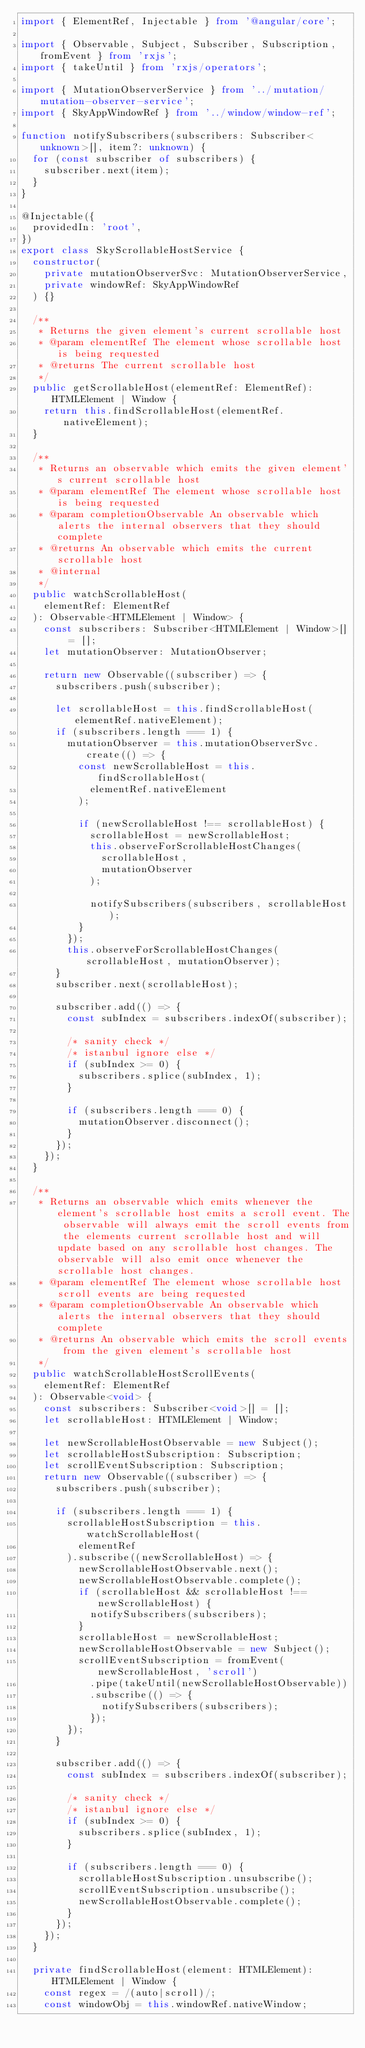Convert code to text. <code><loc_0><loc_0><loc_500><loc_500><_TypeScript_>import { ElementRef, Injectable } from '@angular/core';

import { Observable, Subject, Subscriber, Subscription, fromEvent } from 'rxjs';
import { takeUntil } from 'rxjs/operators';

import { MutationObserverService } from '../mutation/mutation-observer-service';
import { SkyAppWindowRef } from '../window/window-ref';

function notifySubscribers(subscribers: Subscriber<unknown>[], item?: unknown) {
  for (const subscriber of subscribers) {
    subscriber.next(item);
  }
}

@Injectable({
  providedIn: 'root',
})
export class SkyScrollableHostService {
  constructor(
    private mutationObserverSvc: MutationObserverService,
    private windowRef: SkyAppWindowRef
  ) {}

  /**
   * Returns the given element's current scrollable host
   * @param elementRef The element whose scrollable host is being requested
   * @returns The current scrollable host
   */
  public getScrollableHost(elementRef: ElementRef): HTMLElement | Window {
    return this.findScrollableHost(elementRef.nativeElement);
  }

  /**
   * Returns an observable which emits the given element's current scrollable host
   * @param elementRef The element whose scrollable host is being requested
   * @param completionObservable An observable which alerts the internal observers that they should complete
   * @returns An observable which emits the current scrollable host
   * @internal
   */
  public watchScrollableHost(
    elementRef: ElementRef
  ): Observable<HTMLElement | Window> {
    const subscribers: Subscriber<HTMLElement | Window>[] = [];
    let mutationObserver: MutationObserver;

    return new Observable((subscriber) => {
      subscribers.push(subscriber);

      let scrollableHost = this.findScrollableHost(elementRef.nativeElement);
      if (subscribers.length === 1) {
        mutationObserver = this.mutationObserverSvc.create(() => {
          const newScrollableHost = this.findScrollableHost(
            elementRef.nativeElement
          );

          if (newScrollableHost !== scrollableHost) {
            scrollableHost = newScrollableHost;
            this.observeForScrollableHostChanges(
              scrollableHost,
              mutationObserver
            );

            notifySubscribers(subscribers, scrollableHost);
          }
        });
        this.observeForScrollableHostChanges(scrollableHost, mutationObserver);
      }
      subscriber.next(scrollableHost);

      subscriber.add(() => {
        const subIndex = subscribers.indexOf(subscriber);

        /* sanity check */
        /* istanbul ignore else */
        if (subIndex >= 0) {
          subscribers.splice(subIndex, 1);
        }

        if (subscribers.length === 0) {
          mutationObserver.disconnect();
        }
      });
    });
  }

  /**
   * Returns an observable which emits whenever the element's scrollable host emits a scroll event. The observable will always emit the scroll events from the elements current scrollable host and will update based on any scrollable host changes. The observable will also emit once whenever the scrollable host changes.
   * @param elementRef The element whose scrollable host scroll events are being requested
   * @param completionObservable An observable which alerts the internal observers that they should complete
   * @returns An observable which emits the scroll events from the given element's scrollable host
   */
  public watchScrollableHostScrollEvents(
    elementRef: ElementRef
  ): Observable<void> {
    const subscribers: Subscriber<void>[] = [];
    let scrollableHost: HTMLElement | Window;

    let newScrollableHostObservable = new Subject();
    let scrollableHostSubscription: Subscription;
    let scrollEventSubscription: Subscription;
    return new Observable((subscriber) => {
      subscribers.push(subscriber);

      if (subscribers.length === 1) {
        scrollableHostSubscription = this.watchScrollableHost(
          elementRef
        ).subscribe((newScrollableHost) => {
          newScrollableHostObservable.next();
          newScrollableHostObservable.complete();
          if (scrollableHost && scrollableHost !== newScrollableHost) {
            notifySubscribers(subscribers);
          }
          scrollableHost = newScrollableHost;
          newScrollableHostObservable = new Subject();
          scrollEventSubscription = fromEvent(newScrollableHost, 'scroll')
            .pipe(takeUntil(newScrollableHostObservable))
            .subscribe(() => {
              notifySubscribers(subscribers);
            });
        });
      }

      subscriber.add(() => {
        const subIndex = subscribers.indexOf(subscriber);

        /* sanity check */
        /* istanbul ignore else */
        if (subIndex >= 0) {
          subscribers.splice(subIndex, 1);
        }

        if (subscribers.length === 0) {
          scrollableHostSubscription.unsubscribe();
          scrollEventSubscription.unsubscribe();
          newScrollableHostObservable.complete();
        }
      });
    });
  }

  private findScrollableHost(element: HTMLElement): HTMLElement | Window {
    const regex = /(auto|scroll)/;
    const windowObj = this.windowRef.nativeWindow;</code> 